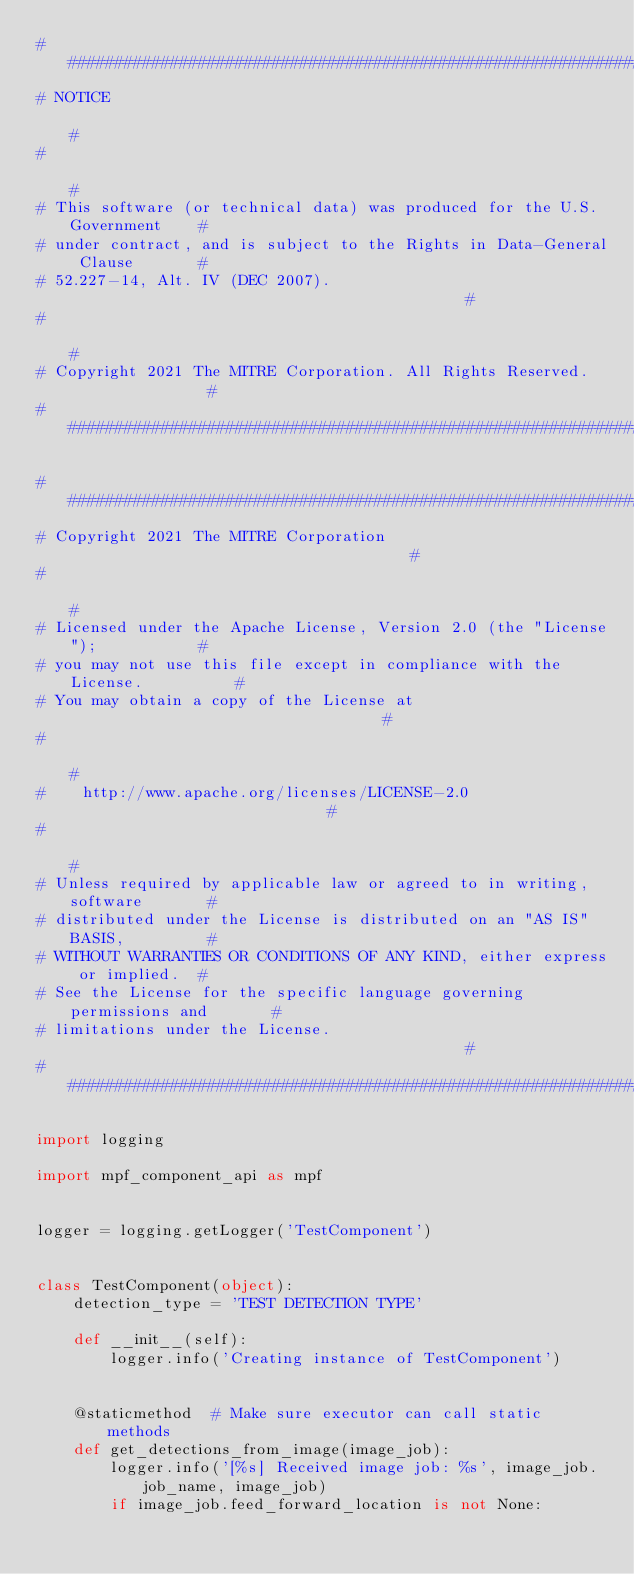<code> <loc_0><loc_0><loc_500><loc_500><_Python_>#############################################################################
# NOTICE                                                                    #
#                                                                           #
# This software (or technical data) was produced for the U.S. Government    #
# under contract, and is subject to the Rights in Data-General Clause       #
# 52.227-14, Alt. IV (DEC 2007).                                            #
#                                                                           #
# Copyright 2021 The MITRE Corporation. All Rights Reserved.                #
#############################################################################

#############################################################################
# Copyright 2021 The MITRE Corporation                                      #
#                                                                           #
# Licensed under the Apache License, Version 2.0 (the "License");           #
# you may not use this file except in compliance with the License.          #
# You may obtain a copy of the License at                                   #
#                                                                           #
#    http://www.apache.org/licenses/LICENSE-2.0                             #
#                                                                           #
# Unless required by applicable law or agreed to in writing, software       #
# distributed under the License is distributed on an "AS IS" BASIS,         #
# WITHOUT WARRANTIES OR CONDITIONS OF ANY KIND, either express or implied.  #
# See the License for the specific language governing permissions and       #
# limitations under the License.                                            #
#############################################################################

import logging

import mpf_component_api as mpf


logger = logging.getLogger('TestComponent')


class TestComponent(object):
    detection_type = 'TEST DETECTION TYPE'

    def __init__(self):
        logger.info('Creating instance of TestComponent')


    @staticmethod  # Make sure executor can call static methods
    def get_detections_from_image(image_job):
        logger.info('[%s] Received image job: %s', image_job.job_name, image_job)
        if image_job.feed_forward_location is not None:</code> 